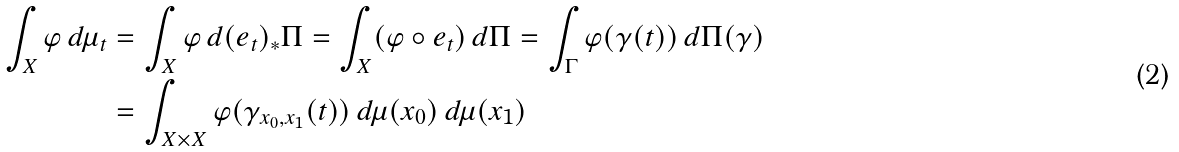Convert formula to latex. <formula><loc_0><loc_0><loc_500><loc_500>\int _ { X } \varphi \, d \mu _ { t } & = \int _ { X } \varphi \, d ( e _ { t } ) _ { * } \Pi = \int _ { X } ( \varphi \circ e _ { t } ) \, d \Pi = \int _ { \Gamma } \varphi ( \gamma ( t ) ) \, d \Pi ( \gamma ) \\ & = \int _ { X \times X } \varphi ( \gamma _ { x _ { 0 } , x _ { 1 } } ( t ) ) \, d \mu ( x _ { 0 } ) \, d \mu ( x _ { 1 } )</formula> 